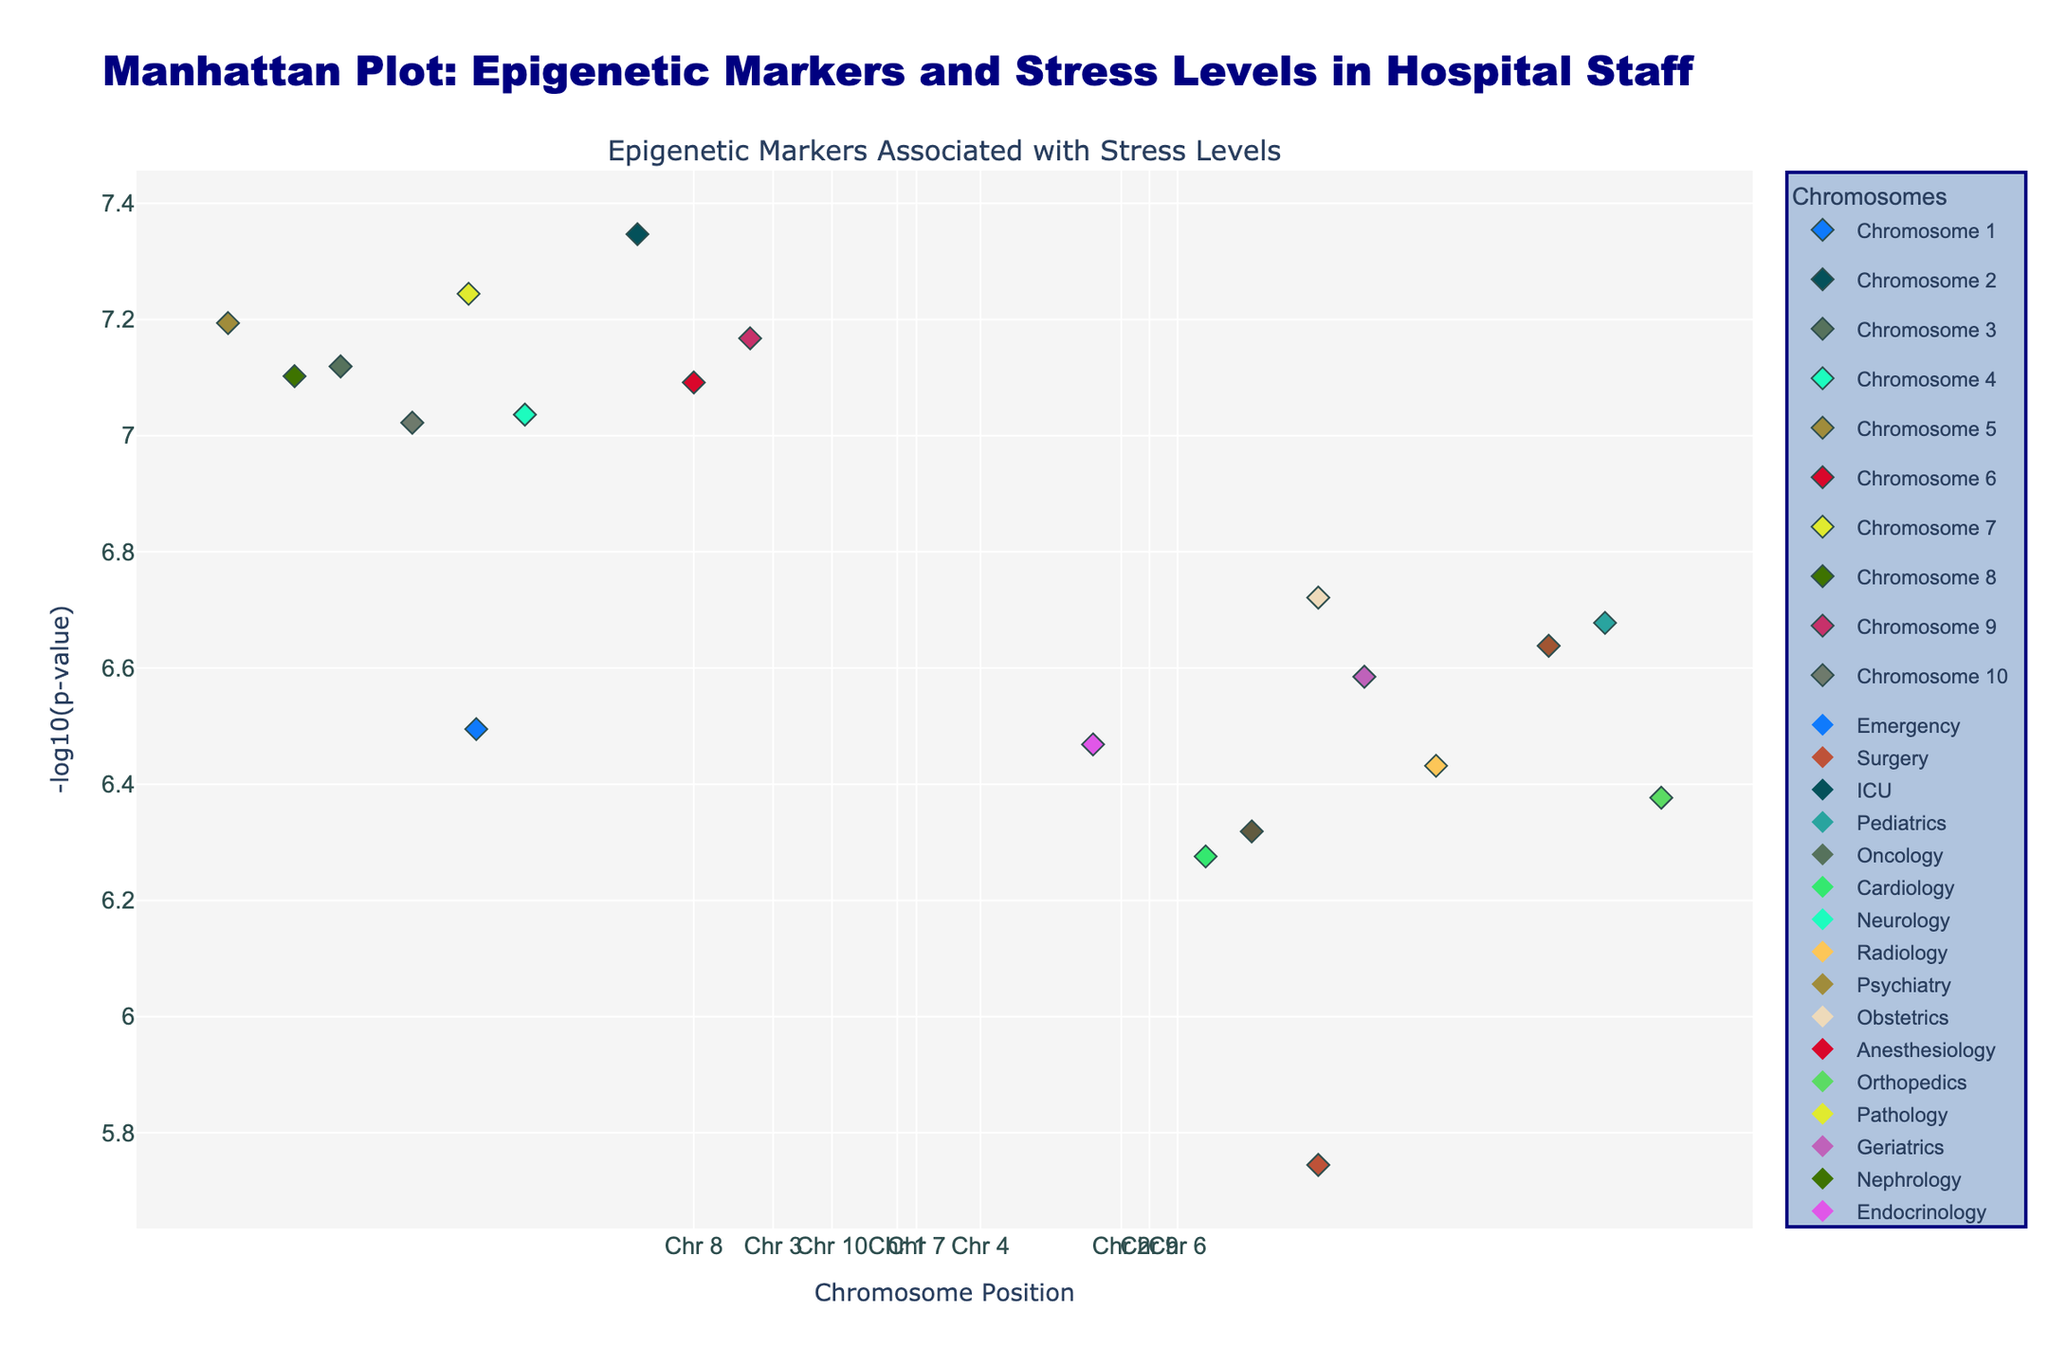What's the title of the figure? The title is typically displayed at the top of the plot. In this case, the title is set in the figure configuration.
Answer: Manhattan Plot: Epigenetic Markers and Stress Levels in Hospital Staff Which axis represents the chromosome position? By looking at the axis labels, it's clear that the x-axis represents 'Chromosome Position'.
Answer: x-axis What does the y-axis represent? The y-axis label indicates that it represents '-log10(p-value)'.
Answer: -log10(p-value) Which department is associated with the most significant p-value on chromosome 2? The most significant p-value on chromosome 2 corresponds to the highest -log10(p-value). Looking at the hover information or legend, it can be seen that the most significant point belongs to the ICU.
Answer: ICU How many chromosomes have data points in the plot? By counting the number of unique chromosomes mentioned in the plot, we can determine that there are data points for chromosomes 1 to 10.
Answer: 10 Which department is represented with the lowest p-value on chromosome 5? Among the data points on chromosome 5, the lowest p-value corresponds to the highest -log10(p-value) value. Referring to the hover information, Psychiatry has the lowest p-value.
Answer: Psychiatry What's the average -log10(p-value) value for the departments on chromosome 4? The -log10(p-value) values for chromosome 4 are calculated and averaged: (-log10(9.2e-8) + -log10(3.7e-7)) / 2. Performing the calculations yields avg = (7.03 + 6.43) / 2 = 6.73.
Answer: 6.73 Which department on chromosome 7 has a higher p-value, Pathology or Geriatrics? The department with a higher p-value will have a lower -log10(p-value). By comparing the values for Pathology and Geriatrics, we see that Geriatrics has a higher p-value.
Answer: Geriatrics What is the range of -log10(p-value) values presented in the plot? Find the minimum and maximum -log10(p-value) values from the plot. The range is calculated by subtracting the minimum value from the maximum: range = max(-log10(p-value)) - min(-log10(p-value)). The highest value is around 7.35 (ICU on chromosome 2), and the lowest is around 6.32 (Orthopedics on chromosome 6), so the range is 7.35 - 6.32 = 1.03.
Answer: 1.03 How many data points represent the Oncology department? By checking the hover information or legend, we count how many markers indicate Oncology, resulting in 1 data point on chromosome 3.
Answer: 1 